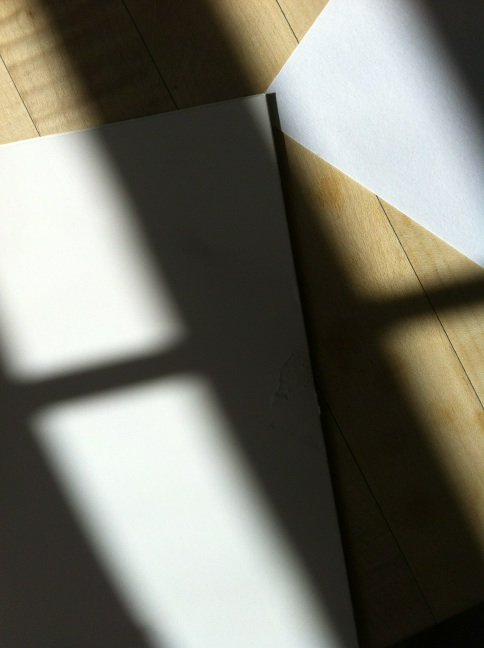What does the lighting reveal about the texture of the materials in the image? The interplay of light and shadow in the image highlights the textural details of the jacket and the flooring. The sharp shadows suggest a stiffer, possibly thicker material for the jacket, while the reflectiveness and grain of the floor could indicate a polished wooden surface. 